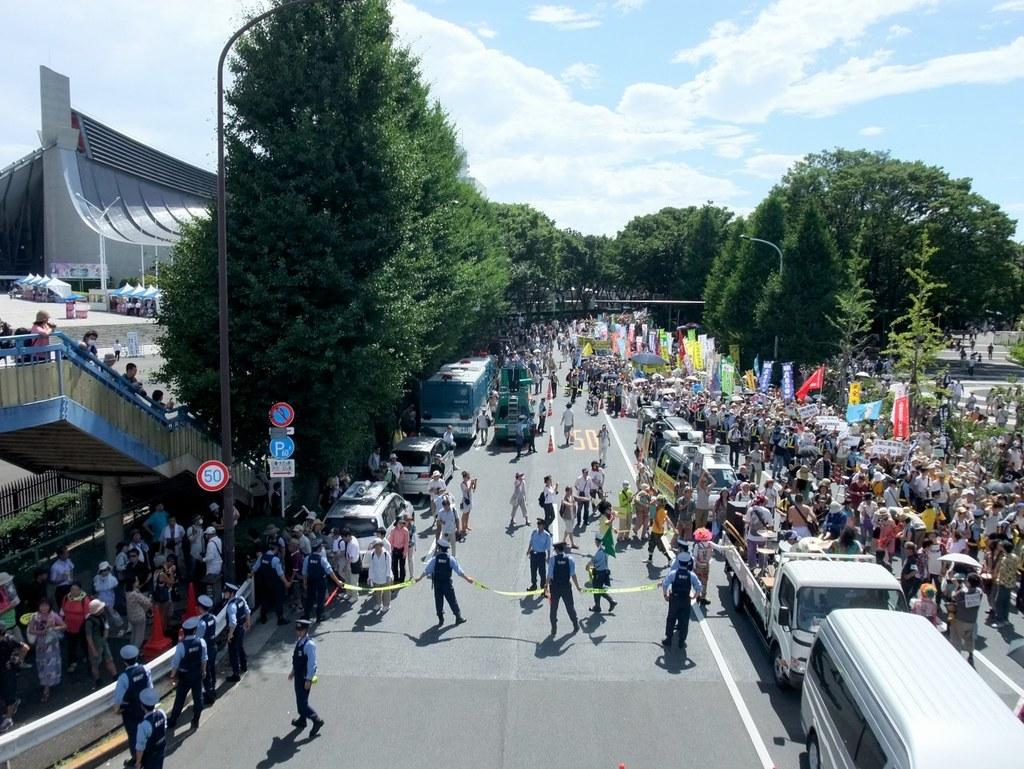Could you give a brief overview of what you see in this image? There is some event going on, on the road some vehicles are moving on the road and around the vehicles there is a huge crowd. On the left side few vehicles are parked beside the footpath and the roads there are plenty of trees, On the left side there is a building and there are two caution boards kept on the footpath and beside those boards many people were standing and there are stairs upwards behind the footpath and people were also standing on those stairs. In the background there is a sky. 